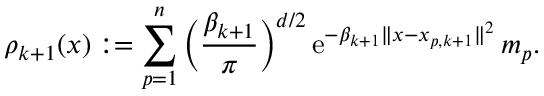Convert formula to latex. <formula><loc_0><loc_0><loc_500><loc_500>\rho _ { k + 1 } ( x ) \colon = \sum _ { p = 1 } ^ { n } \left ( \frac { \beta _ { k + 1 } } { \pi } \right ) ^ { d / 2 } \, e ^ { - \beta _ { k + 1 } \| x - x _ { p , k + 1 } \| ^ { 2 } } \, m _ { p } .</formula> 